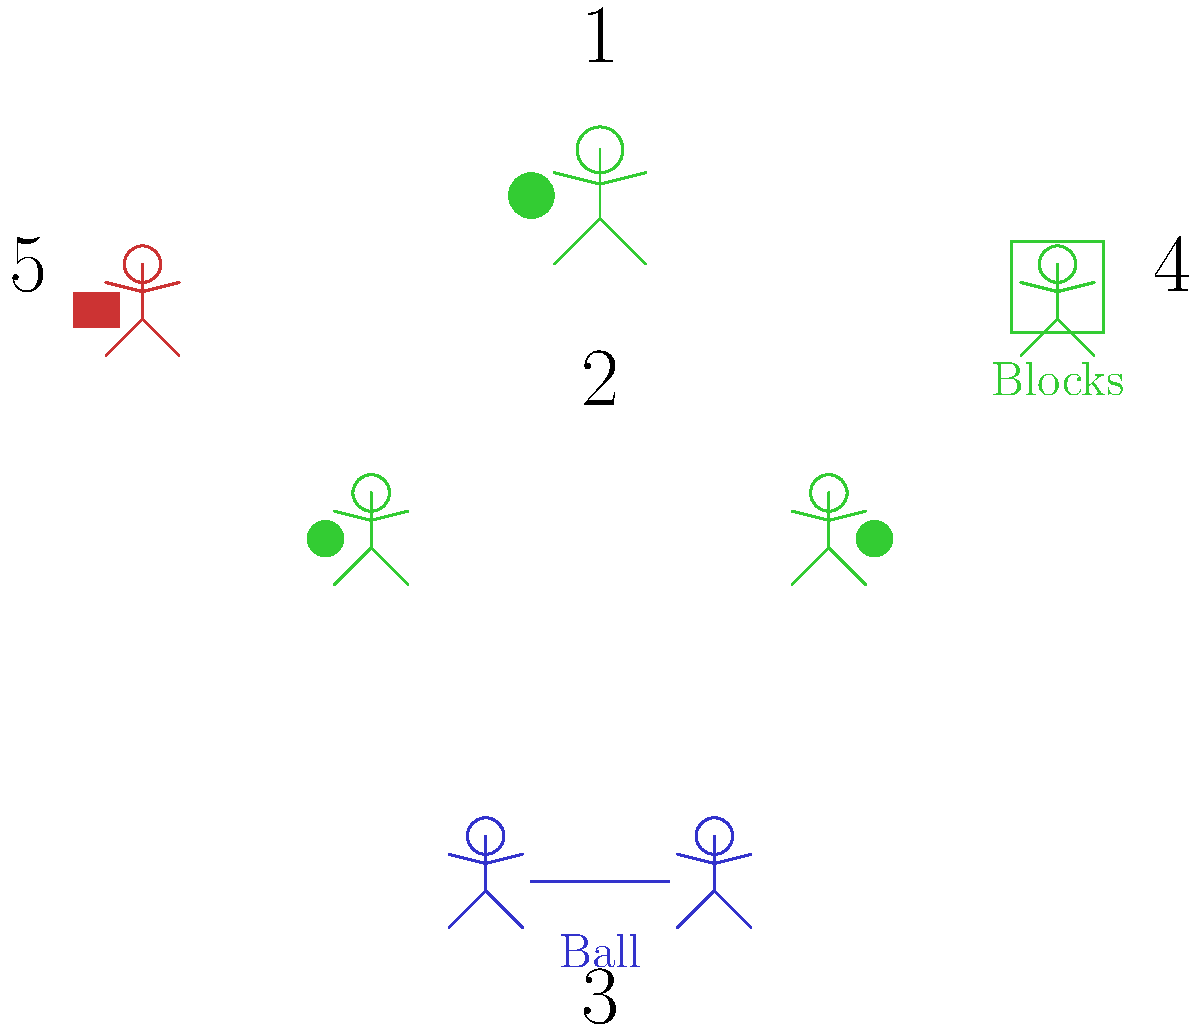Match the pictograms (1-5) with the correct types of play or activity they represent:

a) Cooperative play
b) Solitary play
c) Parallel play
d) Constructive play
e) Studying (non-play activity)

Which pictogram corresponds to each type of play or activity? Let's analyze each pictogram to determine the type of play or activity it represents:

1. Pictogram 1: Shows a single child playing with a ball. This represents solitary play, where a child plays independently.

2. Pictogram 2: Depicts two children playing side by side with their own balls, but not interacting. This illustrates parallel play, where children play near each other but not together.

3. Pictogram 3: Shows two children playing together with a shared ball. This represents cooperative play, where children actively interact and work together.

4. Pictogram 4: Displays a child building with blocks. This exemplifies constructive play, where a child creates or builds something.

5. Pictogram 5: Illustrates a child with a book, engaged in a non-play activity. This represents studying or academic learning.

Matching the pictograms to the types of play or activity:

a) Cooperative play - Pictogram 3
b) Solitary play - Pictogram 1
c) Parallel play - Pictogram 2
d) Constructive play - Pictogram 4
e) Studying (non-play activity) - Pictogram 5
Answer: 1-b, 2-c, 3-a, 4-d, 5-e 